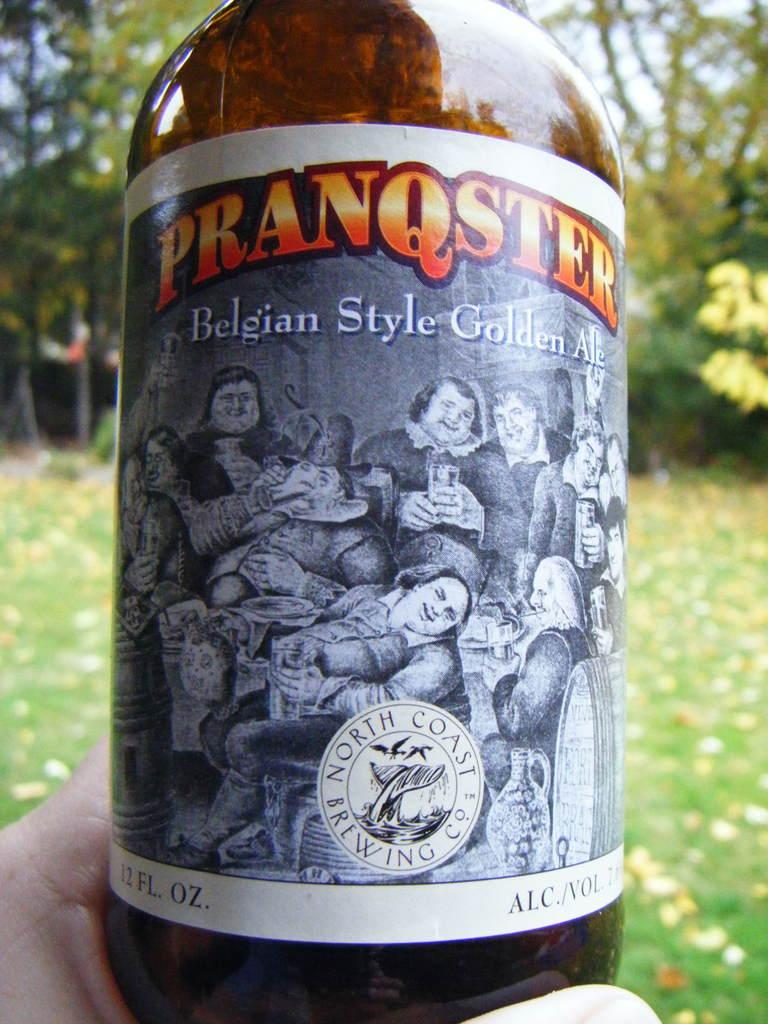<image>
Offer a succinct explanation of the picture presented. A person holding a beer bottle with the label saying Pranqster. 